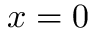Convert formula to latex. <formula><loc_0><loc_0><loc_500><loc_500>x = 0</formula> 